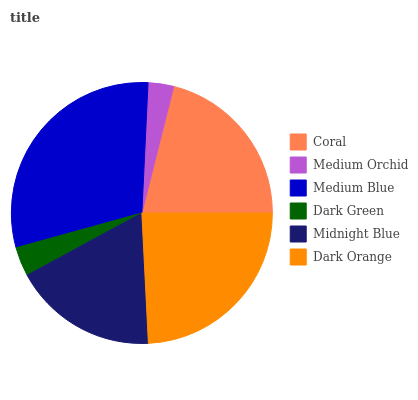Is Medium Orchid the minimum?
Answer yes or no. Yes. Is Medium Blue the maximum?
Answer yes or no. Yes. Is Medium Blue the minimum?
Answer yes or no. No. Is Medium Orchid the maximum?
Answer yes or no. No. Is Medium Blue greater than Medium Orchid?
Answer yes or no. Yes. Is Medium Orchid less than Medium Blue?
Answer yes or no. Yes. Is Medium Orchid greater than Medium Blue?
Answer yes or no. No. Is Medium Blue less than Medium Orchid?
Answer yes or no. No. Is Coral the high median?
Answer yes or no. Yes. Is Midnight Blue the low median?
Answer yes or no. Yes. Is Midnight Blue the high median?
Answer yes or no. No. Is Coral the low median?
Answer yes or no. No. 